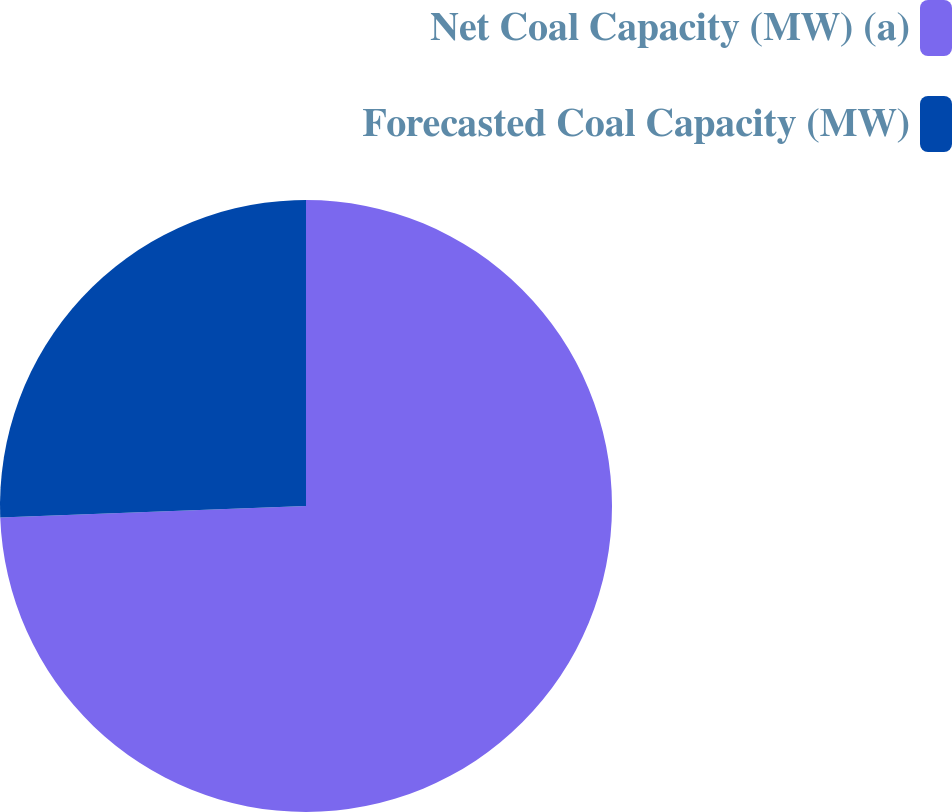Convert chart to OTSL. <chart><loc_0><loc_0><loc_500><loc_500><pie_chart><fcel>Net Coal Capacity (MW) (a)<fcel>Forecasted Coal Capacity (MW)<nl><fcel>74.4%<fcel>25.6%<nl></chart> 